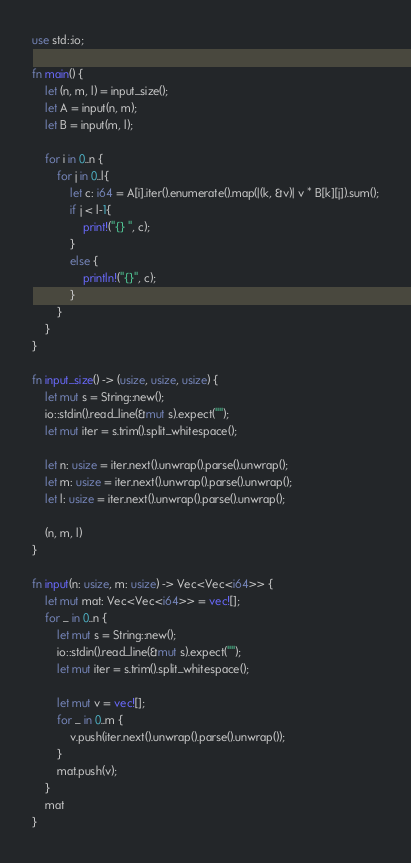Convert code to text. <code><loc_0><loc_0><loc_500><loc_500><_Rust_>use std::io;

fn main() {
    let (n, m, l) = input_size();
    let A = input(n, m);
    let B = input(m, l);

    for i in 0..n {
        for j in 0..l{
            let c: i64 = A[i].iter().enumerate().map(|(k, &v)| v * B[k][j]).sum();
            if j < l-1{
                print!("{} ", c);
            }
            else {
                println!("{}", c);
            }
        }
    }
}

fn input_size() -> (usize, usize, usize) {
    let mut s = String::new();
    io::stdin().read_line(&mut s).expect("");
    let mut iter = s.trim().split_whitespace();

    let n: usize = iter.next().unwrap().parse().unwrap();
    let m: usize = iter.next().unwrap().parse().unwrap();
    let l: usize = iter.next().unwrap().parse().unwrap();

    (n, m, l)
}

fn input(n: usize, m: usize) -> Vec<Vec<i64>> {
    let mut mat: Vec<Vec<i64>> = vec![];
    for _ in 0..n {
        let mut s = String::new();
        io::stdin().read_line(&mut s).expect("");
        let mut iter = s.trim().split_whitespace();

        let mut v = vec![];
        for _ in 0..m {
            v.push(iter.next().unwrap().parse().unwrap());
        }
        mat.push(v);
    }
    mat
}
</code> 